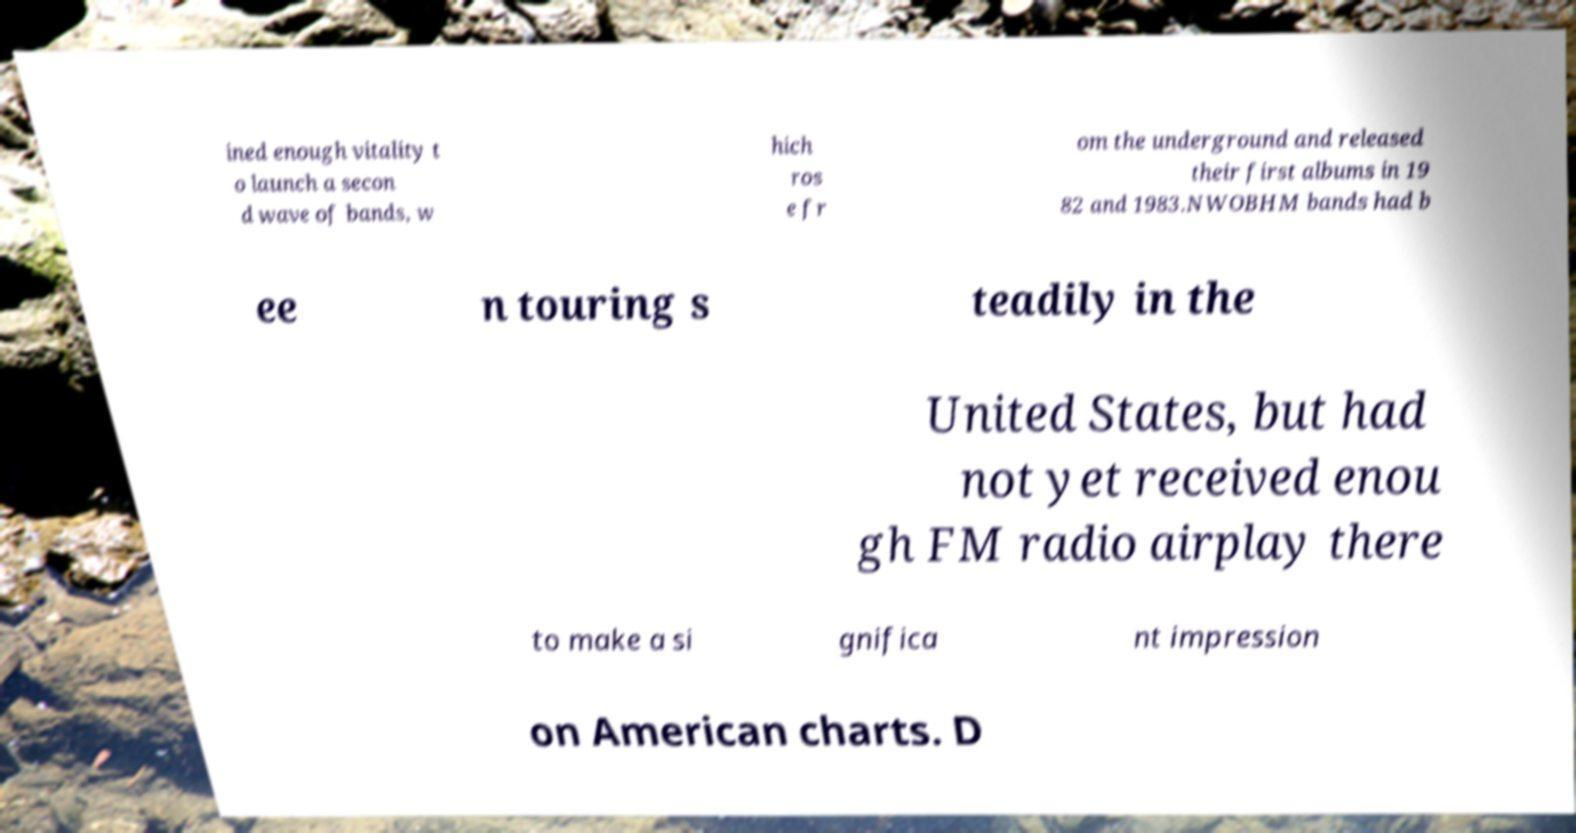For documentation purposes, I need the text within this image transcribed. Could you provide that? ined enough vitality t o launch a secon d wave of bands, w hich ros e fr om the underground and released their first albums in 19 82 and 1983.NWOBHM bands had b ee n touring s teadily in the United States, but had not yet received enou gh FM radio airplay there to make a si gnifica nt impression on American charts. D 